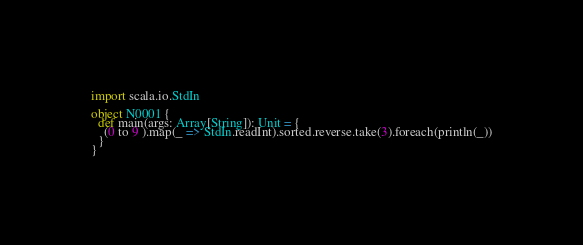Convert code to text. <code><loc_0><loc_0><loc_500><loc_500><_Scala_>import scala.io.StdIn

object N0001 {
  def main(args: Array[String]): Unit = {
    (0 to 9 ).map(_ => StdIn.readInt).sorted.reverse.take(3).foreach(println(_))
  }
}</code> 